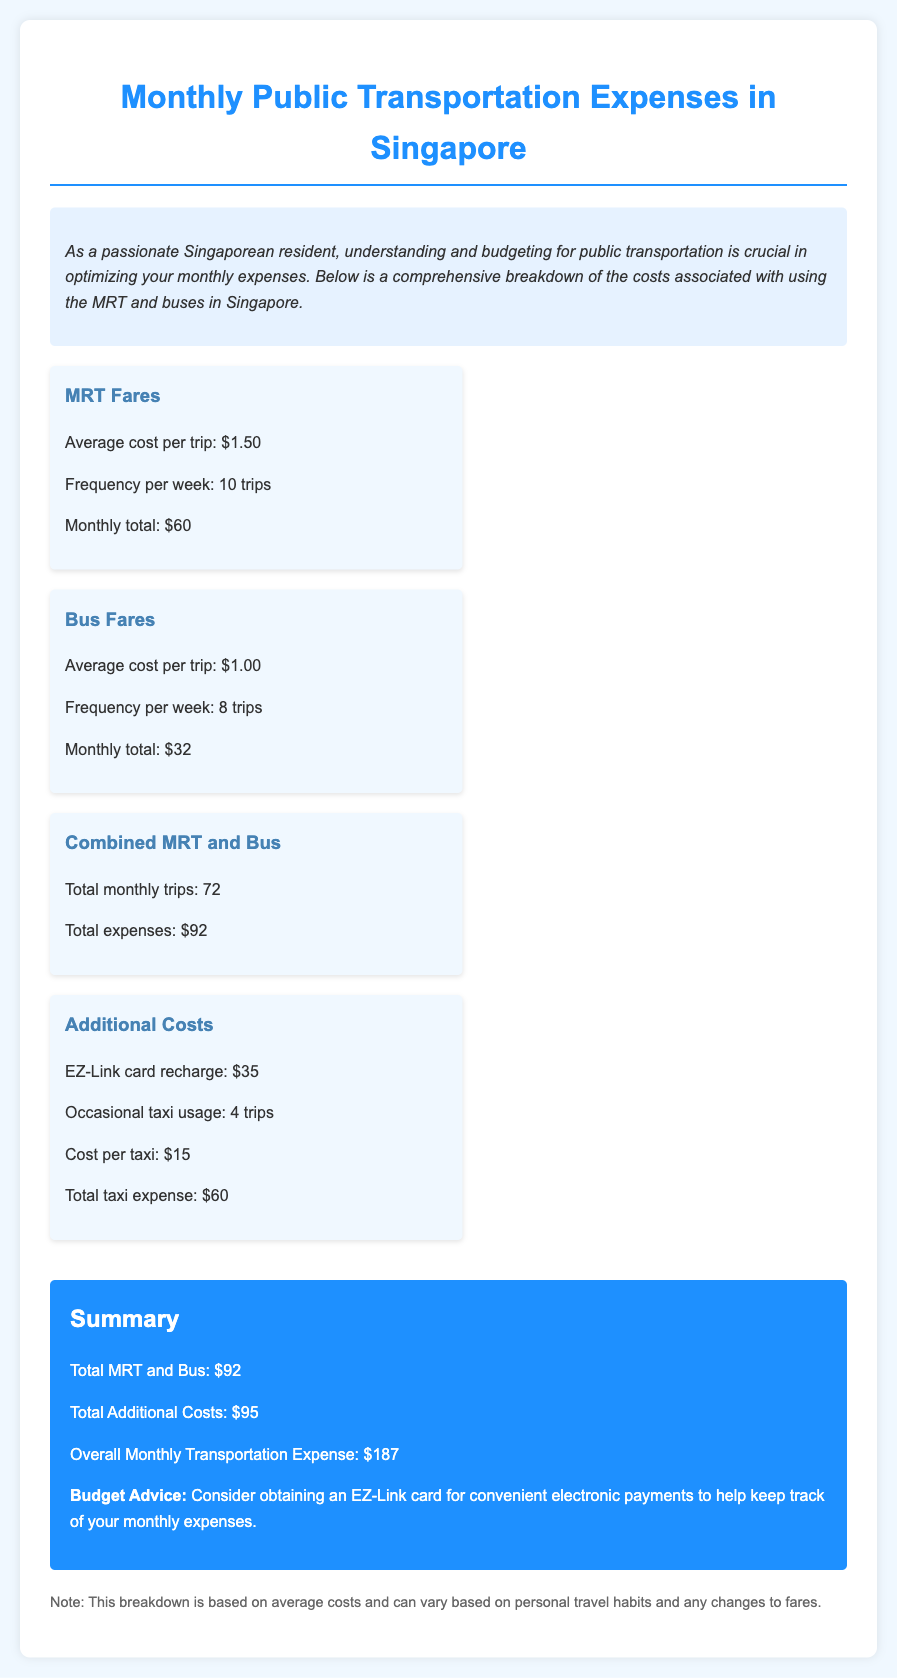what is the average cost per MRT trip? The document states that the average cost per MRT trip is $1.50.
Answer: $1.50 what is the frequency of bus trips per week? The document mentions that the frequency of bus trips per week is 8 trips.
Answer: 8 trips what is the total monthly MRT expense? The monthly total for MRT fares is provided as $60.
Answer: $60 how many total additional costs are there? The total additional costs are detailed under the "Additional Costs" section, which adds up to $95.
Answer: $95 what is the overall monthly transportation expense? The document summarizes the overall monthly transportation expense as $187.
Answer: $187 what is the cost per taxi trip? It states that the cost per taxi trip is $15.
Answer: $15 how many occasional taxi trips are incurred? The document lists the number of occasional taxi trips as 4 trips.
Answer: 4 trips what is the total monthly bus expense? The total calculated for bus fares in the document is $32.
Answer: $32 what is the total number of trips made monthly for MRT and bus combined? The document states the total number of combined trips for MRT and bus is 72.
Answer: 72 trips 